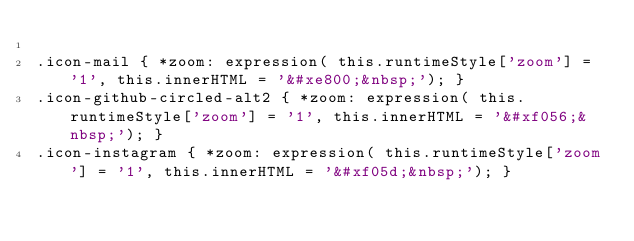Convert code to text. <code><loc_0><loc_0><loc_500><loc_500><_CSS_>
.icon-mail { *zoom: expression( this.runtimeStyle['zoom'] = '1', this.innerHTML = '&#xe800;&nbsp;'); }
.icon-github-circled-alt2 { *zoom: expression( this.runtimeStyle['zoom'] = '1', this.innerHTML = '&#xf056;&nbsp;'); }
.icon-instagram { *zoom: expression( this.runtimeStyle['zoom'] = '1', this.innerHTML = '&#xf05d;&nbsp;'); }</code> 